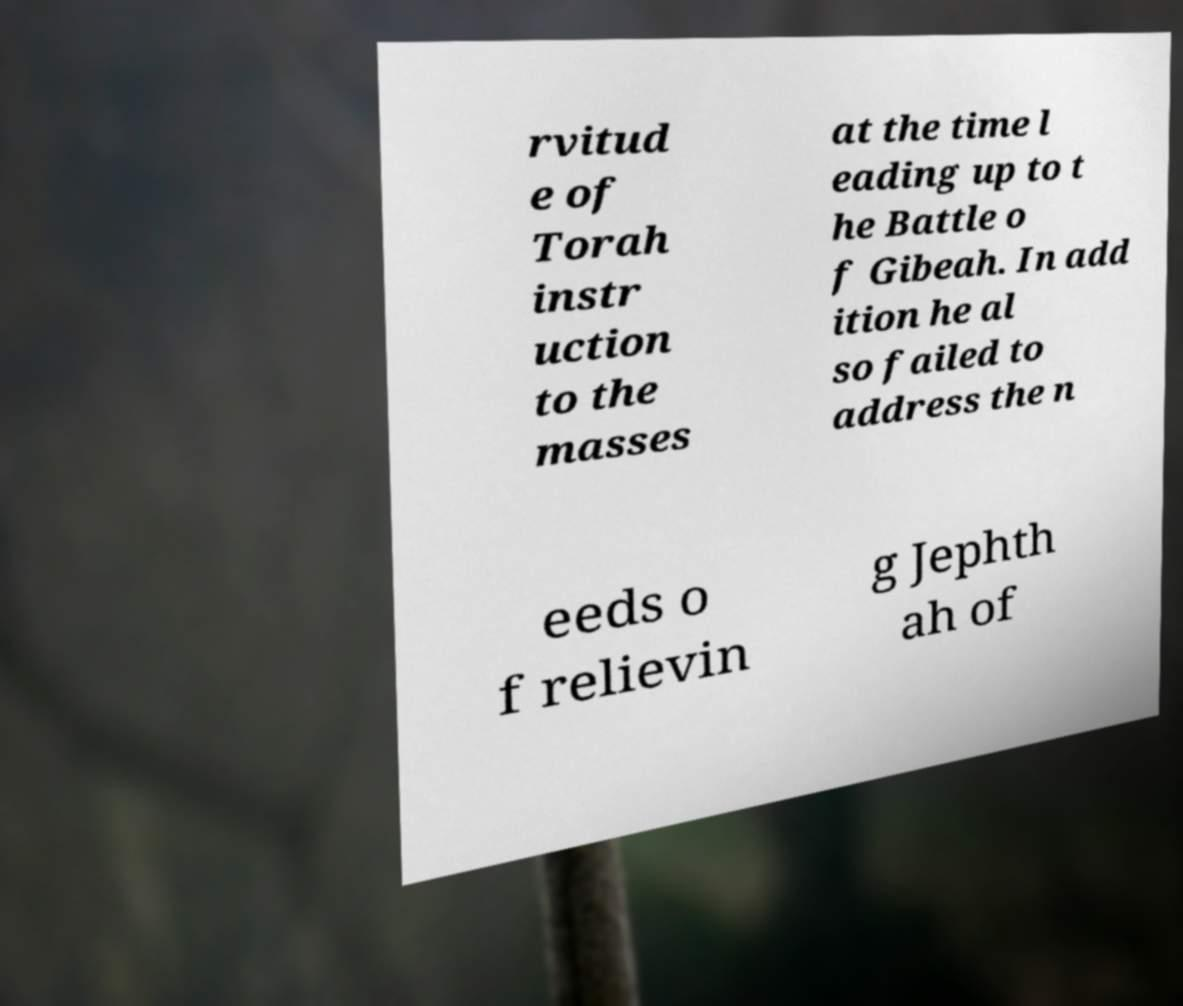Could you extract and type out the text from this image? rvitud e of Torah instr uction to the masses at the time l eading up to t he Battle o f Gibeah. In add ition he al so failed to address the n eeds o f relievin g Jephth ah of 